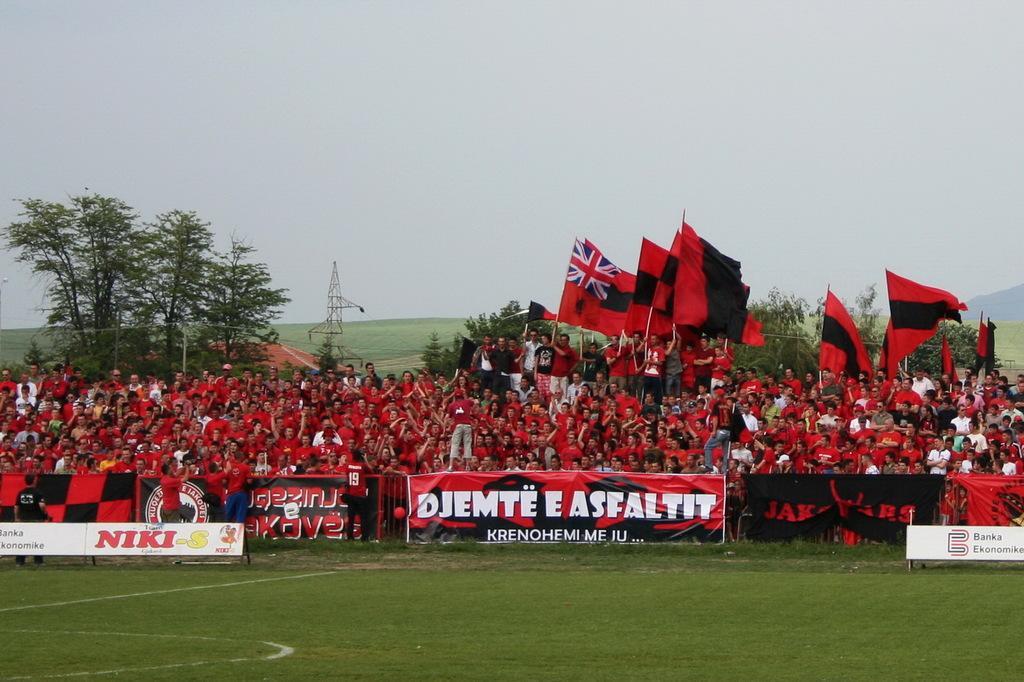Can you describe this image briefly? In the center of the image there are many people wearing red color dress. There are people holding flags. At the bottom of the image there is grass. In the background of the image there is a tower. There are trees. 